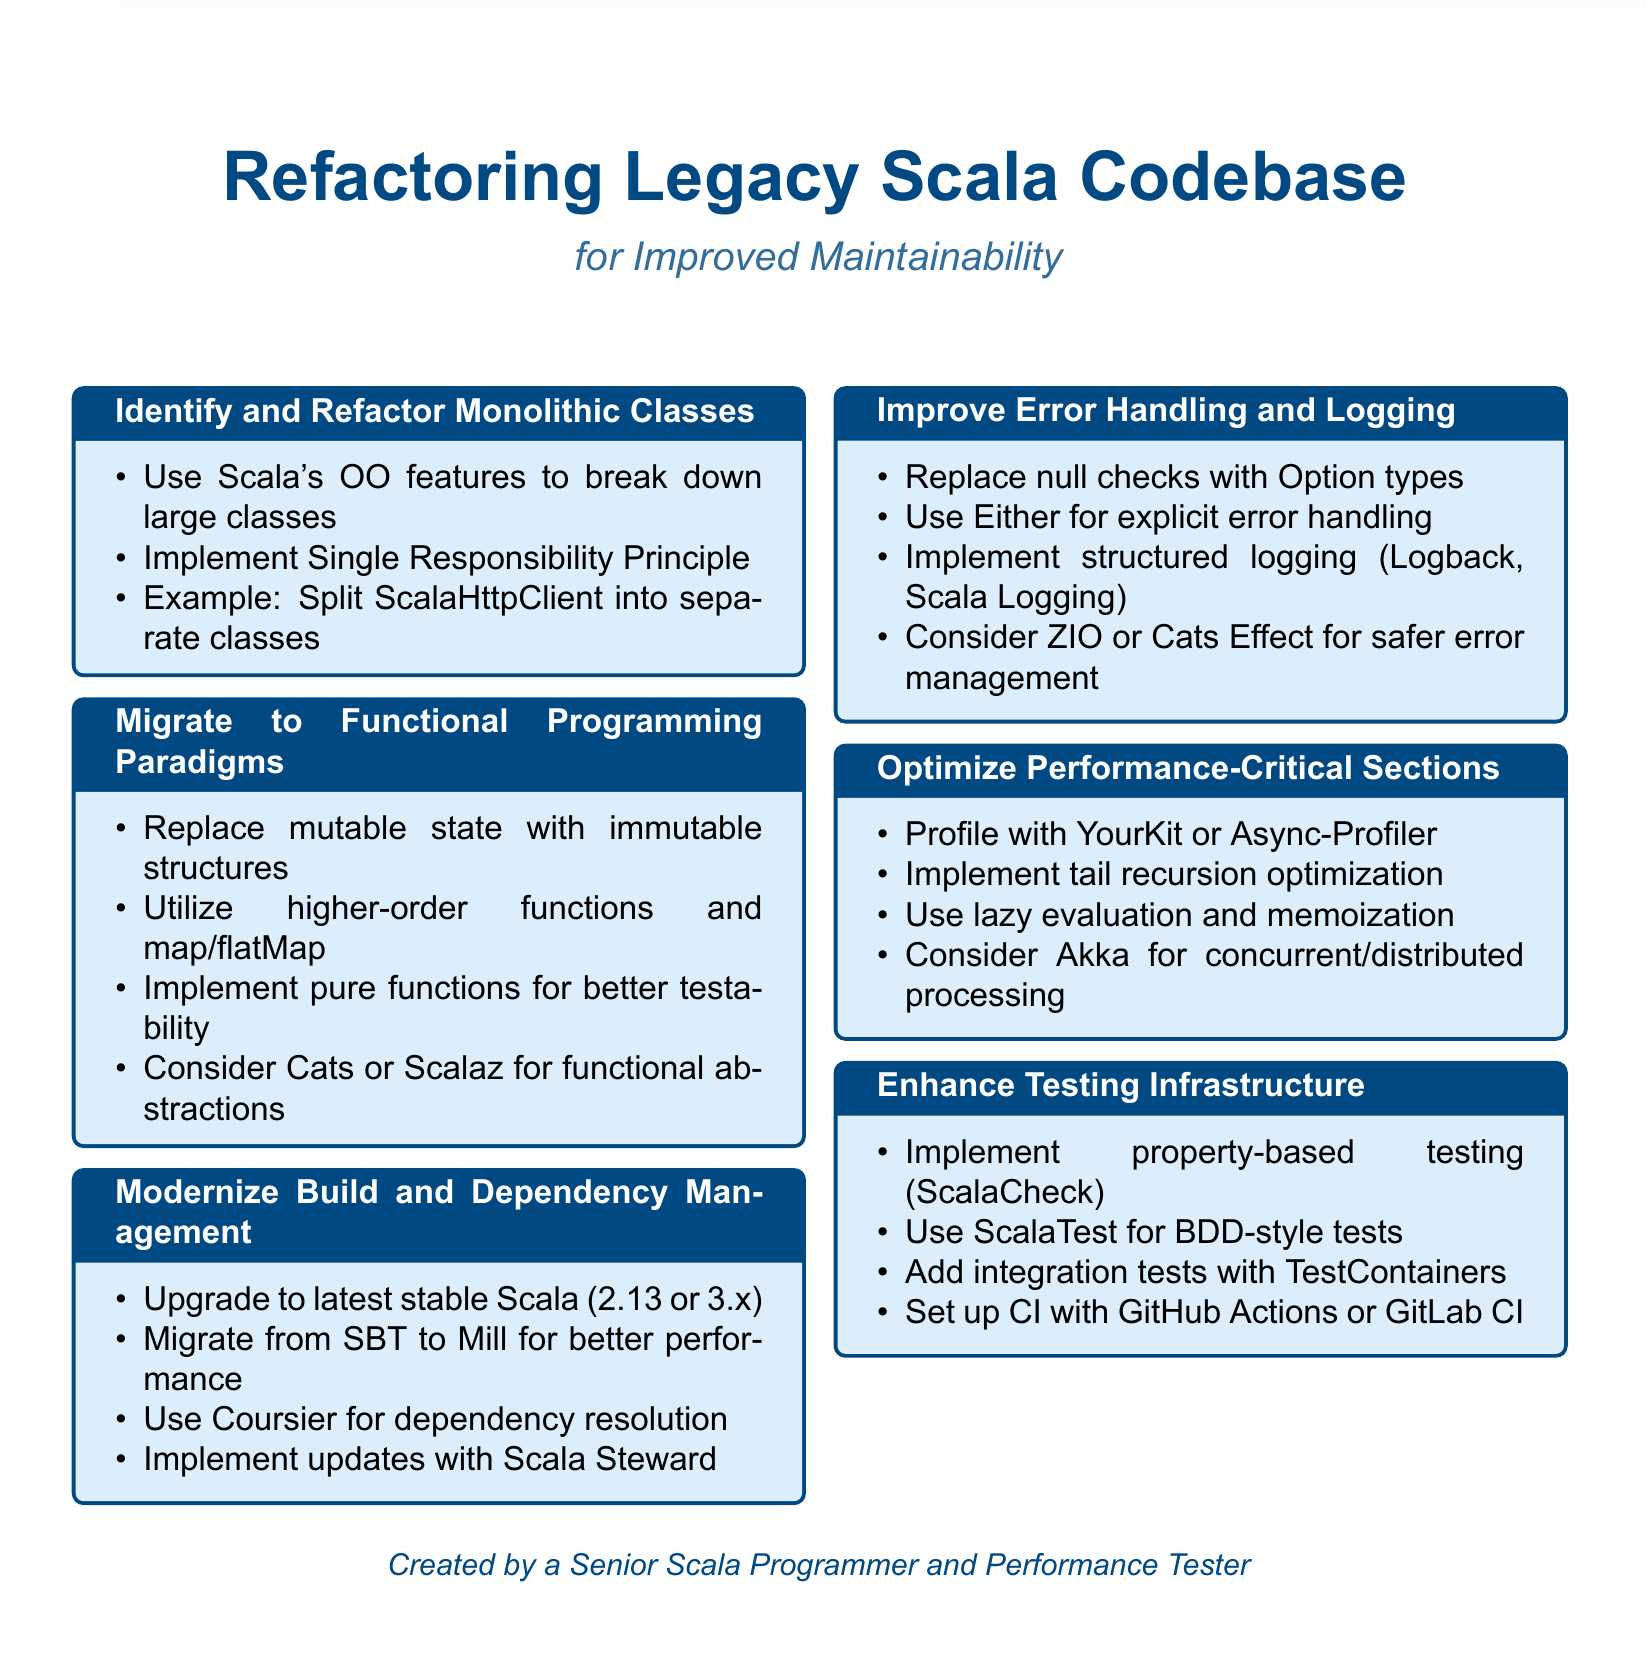What is the title of the document? The title is listed at the beginning of the document and indicates the main focus on legacy Scala codebase refactoring.
Answer: Refactoring Legacy Scala Codebase for Improved Maintainability What principle is emphasized for monolithic classes? The document specifies the Single Responsibility Principle as a guideline for refactoring.
Answer: Single Responsibility Principle Which libraries are suggested for functional programming abstractions? The document mentions specific libraries that help with functional programming principles in Scala.
Answer: Cats or Scalaz What testing framework is recommended for behavior-driven development? The document recommends using a specific framework for implementing BDD-style tests.
Answer: ScalaTest How should null checks be replaced according to the document? The document advises replacing null checks with a type that represents optional values to enhance safety.
Answer: Option types What optimization technique is suggested for recursive functions? The document specifically mentions an optimization technique aimed at improving recursive function performance.
Answer: Tail recursion optimization Which tool is recommended for profiling the application? The document identifies a tool suitable for profiling to enhance performance analysis.
Answer: YourKit or Async-Profiler What is the goal of migrating to Mill? The document addresses the benefits of switching build tools in terms of performance improvements.
Answer: Improved build performance How many sections are outlined in the document? The document is organized into multiple distinct sections that address various refactoring strategies.
Answer: Six 